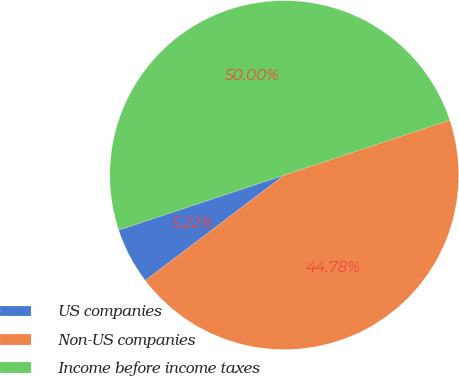Convert chart. <chart><loc_0><loc_0><loc_500><loc_500><pie_chart><fcel>US companies<fcel>Non-US companies<fcel>Income before income taxes<nl><fcel>5.22%<fcel>44.78%<fcel>50.0%<nl></chart> 